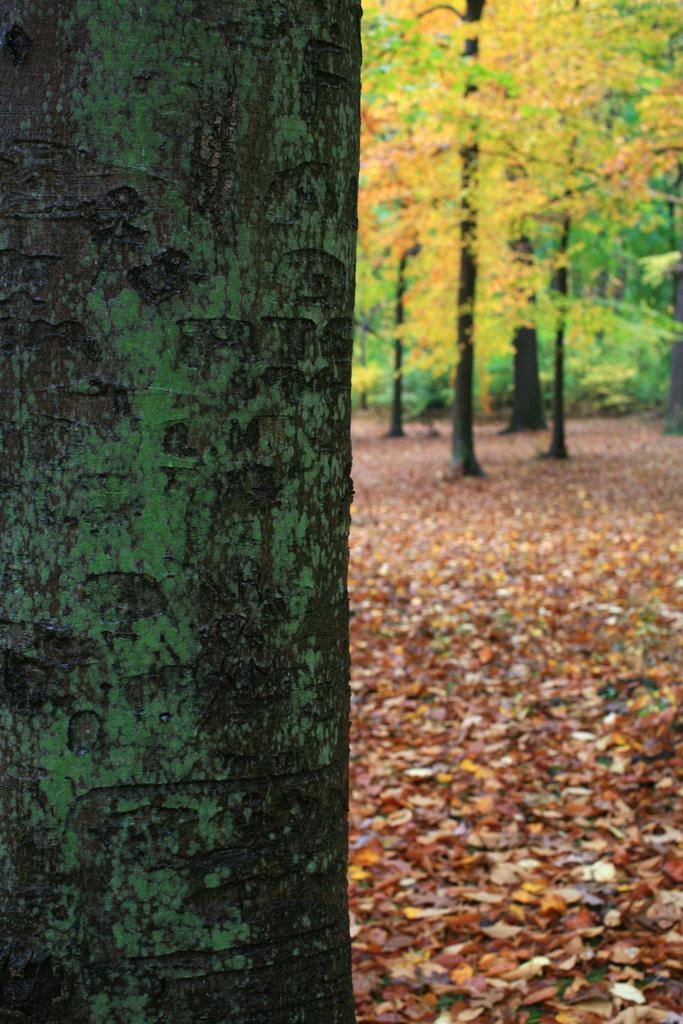Could you give a brief overview of what you see in this image? In the given image i can see a tree trunk,trees and grass. 